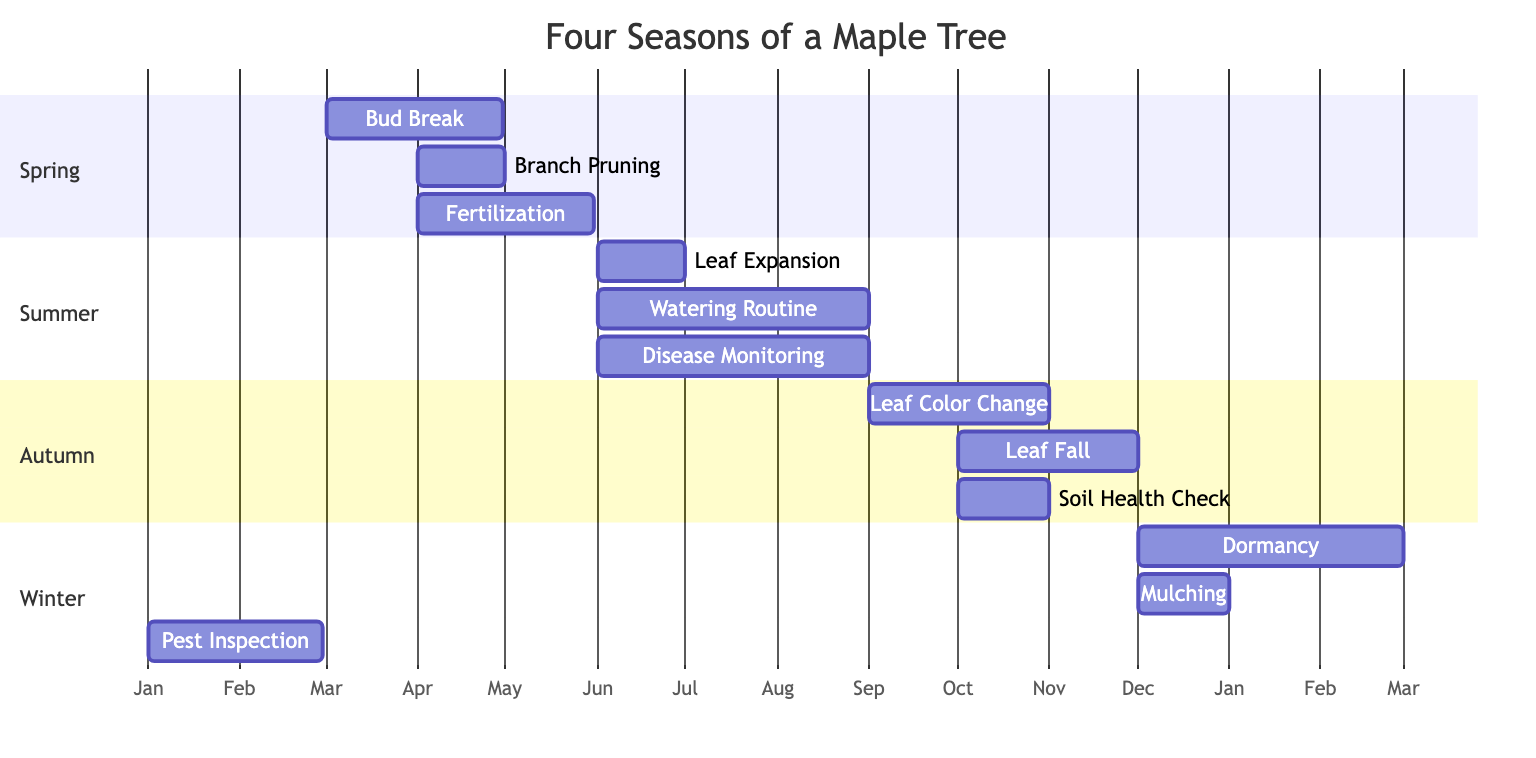What is the duration of Bud Break? The diagram shows that Bud Break starts in March and lasts for 60 days. Counting from March 1, it continues through April, providing a clear duration of 60 days.
Answer: 60 days How many activities are planned in Summer? Looking at the Summer section, I can see there are three listed activities: Leaf Expansion, Watering Routine, and Disease Monitoring. This gives a total of three activities for the Summer season.
Answer: 3 Which activity occurs last in Autumn? In the Autumn section, Leaf Fall starts in October and ends in November. It is the only activity that begins later than others, making it the last one in the Autumn season.
Answer: Leaf Fall What is the earliest activity shown for Winter? The Winter section lists Dormancy, which starts in December. Since it is the first listed activity, it represents the earliest activity in that season.
Answer: Dormancy How long does the Watering Routine last? The diagram indicates that the Watering Routine occurs from June 1 for 92 days. By adding this time frame to June, it extends into late August, confirming the total duration of 92 days.
Answer: 92 days Which season includes Soil Health Check? The diagram places Soil Health Check under the Autumn section. It is also specifically marked with a time frame starting and ending in October, clearly identifying its seasonal placement.
Answer: Autumn How many total activities are showcased across all seasons? By analyzing each season's activities, I find that Spring has three, Summer has three, Autumn has three, and Winter has three. Adding these together, the total number of activities is twelve.
Answer: 12 What activity is performed in December other than Dormancy? According to the diagram, Mulching is also scheduled for December in the Winter section, in addition to Dormancy. This shows that two activities are planned for December.
Answer: Mulching 